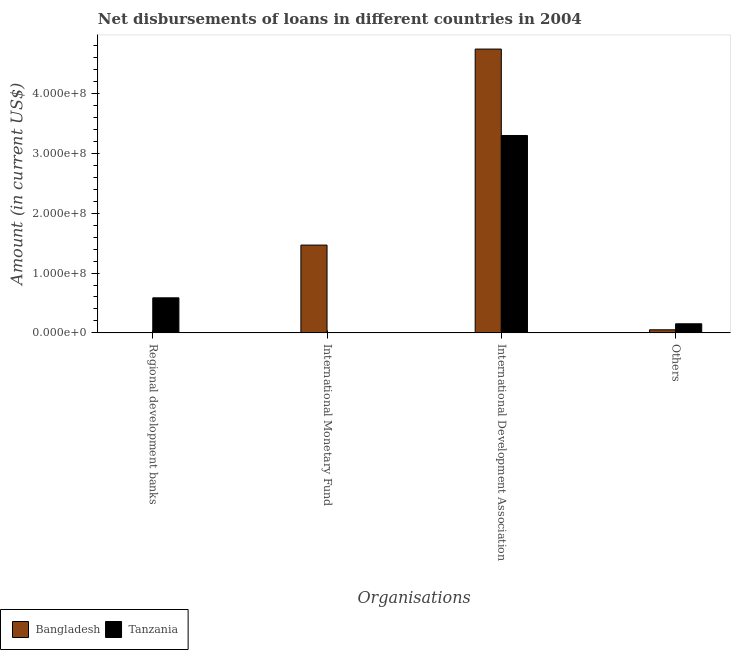Are the number of bars per tick equal to the number of legend labels?
Your response must be concise. No. What is the label of the 1st group of bars from the left?
Keep it short and to the point. Regional development banks. What is the amount of loan disimbursed by other organisations in Bangladesh?
Make the answer very short. 5.12e+06. Across all countries, what is the maximum amount of loan disimbursed by international development association?
Your answer should be very brief. 4.74e+08. Across all countries, what is the minimum amount of loan disimbursed by other organisations?
Your response must be concise. 5.12e+06. In which country was the amount of loan disimbursed by regional development banks maximum?
Make the answer very short. Tanzania. What is the total amount of loan disimbursed by regional development banks in the graph?
Keep it short and to the point. 5.86e+07. What is the difference between the amount of loan disimbursed by other organisations in Bangladesh and that in Tanzania?
Your answer should be very brief. -1.01e+07. What is the difference between the amount of loan disimbursed by international development association in Tanzania and the amount of loan disimbursed by other organisations in Bangladesh?
Keep it short and to the point. 3.25e+08. What is the average amount of loan disimbursed by regional development banks per country?
Your answer should be compact. 2.93e+07. What is the difference between the amount of loan disimbursed by other organisations and amount of loan disimbursed by international monetary fund in Bangladesh?
Your response must be concise. -1.42e+08. What is the ratio of the amount of loan disimbursed by international development association in Bangladesh to that in Tanzania?
Give a very brief answer. 1.44. What is the difference between the highest and the second highest amount of loan disimbursed by international development association?
Ensure brevity in your answer.  1.44e+08. What is the difference between the highest and the lowest amount of loan disimbursed by regional development banks?
Provide a short and direct response. 5.86e+07. In how many countries, is the amount of loan disimbursed by international development association greater than the average amount of loan disimbursed by international development association taken over all countries?
Keep it short and to the point. 1. Is it the case that in every country, the sum of the amount of loan disimbursed by other organisations and amount of loan disimbursed by international development association is greater than the sum of amount of loan disimbursed by international monetary fund and amount of loan disimbursed by regional development banks?
Provide a succinct answer. No. Is it the case that in every country, the sum of the amount of loan disimbursed by regional development banks and amount of loan disimbursed by international monetary fund is greater than the amount of loan disimbursed by international development association?
Offer a terse response. No. How many bars are there?
Make the answer very short. 6. Are all the bars in the graph horizontal?
Provide a succinct answer. No. What is the difference between two consecutive major ticks on the Y-axis?
Provide a short and direct response. 1.00e+08. Does the graph contain any zero values?
Provide a short and direct response. Yes. Where does the legend appear in the graph?
Keep it short and to the point. Bottom left. What is the title of the graph?
Your response must be concise. Net disbursements of loans in different countries in 2004. What is the label or title of the X-axis?
Provide a short and direct response. Organisations. What is the label or title of the Y-axis?
Make the answer very short. Amount (in current US$). What is the Amount (in current US$) of Tanzania in Regional development banks?
Offer a very short reply. 5.86e+07. What is the Amount (in current US$) in Bangladesh in International Monetary Fund?
Your answer should be very brief. 1.47e+08. What is the Amount (in current US$) of Bangladesh in International Development Association?
Your answer should be compact. 4.74e+08. What is the Amount (in current US$) of Tanzania in International Development Association?
Make the answer very short. 3.30e+08. What is the Amount (in current US$) in Bangladesh in Others?
Keep it short and to the point. 5.12e+06. What is the Amount (in current US$) of Tanzania in Others?
Make the answer very short. 1.52e+07. Across all Organisations, what is the maximum Amount (in current US$) in Bangladesh?
Your response must be concise. 4.74e+08. Across all Organisations, what is the maximum Amount (in current US$) in Tanzania?
Provide a short and direct response. 3.30e+08. Across all Organisations, what is the minimum Amount (in current US$) in Bangladesh?
Your answer should be very brief. 0. Across all Organisations, what is the minimum Amount (in current US$) of Tanzania?
Keep it short and to the point. 0. What is the total Amount (in current US$) in Bangladesh in the graph?
Offer a terse response. 6.26e+08. What is the total Amount (in current US$) in Tanzania in the graph?
Give a very brief answer. 4.04e+08. What is the difference between the Amount (in current US$) of Tanzania in Regional development banks and that in International Development Association?
Your response must be concise. -2.71e+08. What is the difference between the Amount (in current US$) of Tanzania in Regional development banks and that in Others?
Your response must be concise. 4.34e+07. What is the difference between the Amount (in current US$) in Bangladesh in International Monetary Fund and that in International Development Association?
Your answer should be very brief. -3.28e+08. What is the difference between the Amount (in current US$) in Bangladesh in International Monetary Fund and that in Others?
Your answer should be very brief. 1.42e+08. What is the difference between the Amount (in current US$) in Bangladesh in International Development Association and that in Others?
Offer a very short reply. 4.69e+08. What is the difference between the Amount (in current US$) of Tanzania in International Development Association and that in Others?
Make the answer very short. 3.15e+08. What is the difference between the Amount (in current US$) in Bangladesh in International Monetary Fund and the Amount (in current US$) in Tanzania in International Development Association?
Keep it short and to the point. -1.83e+08. What is the difference between the Amount (in current US$) of Bangladesh in International Monetary Fund and the Amount (in current US$) of Tanzania in Others?
Make the answer very short. 1.32e+08. What is the difference between the Amount (in current US$) in Bangladesh in International Development Association and the Amount (in current US$) in Tanzania in Others?
Your response must be concise. 4.59e+08. What is the average Amount (in current US$) of Bangladesh per Organisations?
Provide a succinct answer. 1.57e+08. What is the average Amount (in current US$) in Tanzania per Organisations?
Offer a very short reply. 1.01e+08. What is the difference between the Amount (in current US$) in Bangladesh and Amount (in current US$) in Tanzania in International Development Association?
Provide a short and direct response. 1.44e+08. What is the difference between the Amount (in current US$) of Bangladesh and Amount (in current US$) of Tanzania in Others?
Your response must be concise. -1.01e+07. What is the ratio of the Amount (in current US$) in Tanzania in Regional development banks to that in International Development Association?
Make the answer very short. 0.18. What is the ratio of the Amount (in current US$) of Tanzania in Regional development banks to that in Others?
Keep it short and to the point. 3.86. What is the ratio of the Amount (in current US$) of Bangladesh in International Monetary Fund to that in International Development Association?
Make the answer very short. 0.31. What is the ratio of the Amount (in current US$) in Bangladesh in International Monetary Fund to that in Others?
Ensure brevity in your answer.  28.68. What is the ratio of the Amount (in current US$) of Bangladesh in International Development Association to that in Others?
Keep it short and to the point. 92.72. What is the ratio of the Amount (in current US$) in Tanzania in International Development Association to that in Others?
Your answer should be very brief. 21.74. What is the difference between the highest and the second highest Amount (in current US$) in Bangladesh?
Make the answer very short. 3.28e+08. What is the difference between the highest and the second highest Amount (in current US$) in Tanzania?
Provide a short and direct response. 2.71e+08. What is the difference between the highest and the lowest Amount (in current US$) of Bangladesh?
Make the answer very short. 4.74e+08. What is the difference between the highest and the lowest Amount (in current US$) of Tanzania?
Provide a succinct answer. 3.30e+08. 